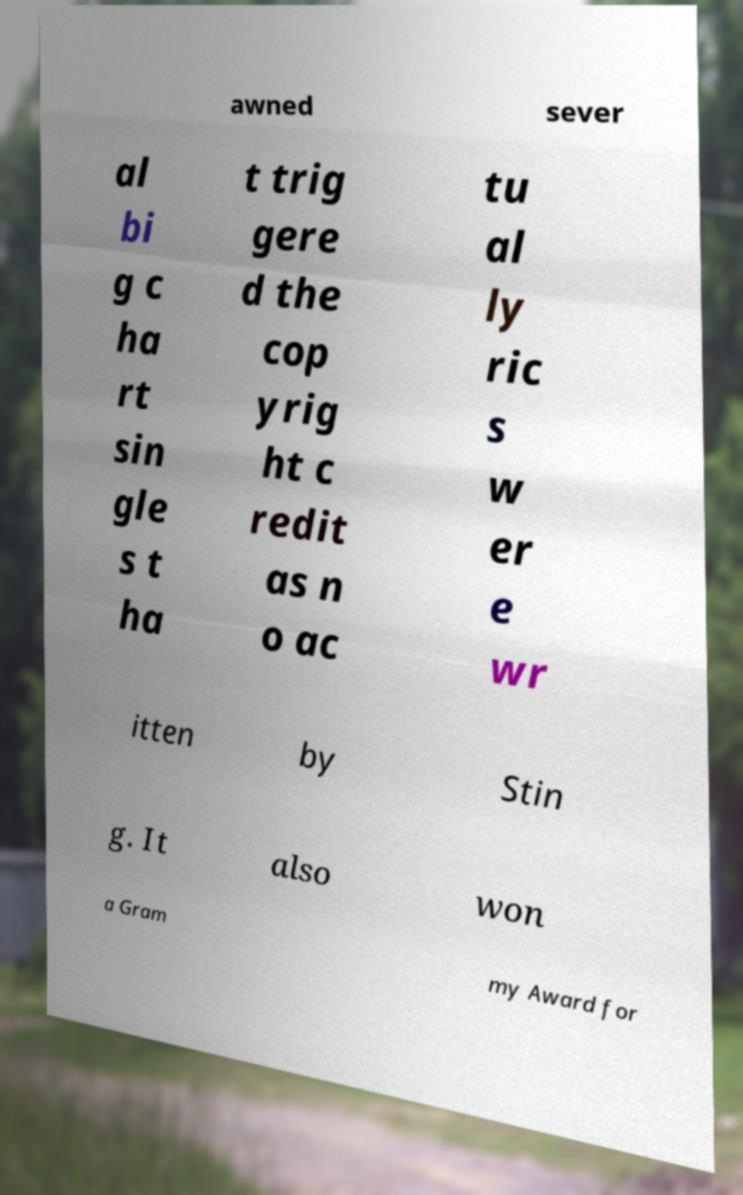Can you read and provide the text displayed in the image?This photo seems to have some interesting text. Can you extract and type it out for me? awned sever al bi g c ha rt sin gle s t ha t trig gere d the cop yrig ht c redit as n o ac tu al ly ric s w er e wr itten by Stin g. It also won a Gram my Award for 